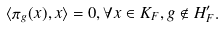Convert formula to latex. <formula><loc_0><loc_0><loc_500><loc_500>\langle \pi _ { g } ( x ) , x \rangle = 0 , \forall x \in K _ { F } , g \notin H ^ { \prime } _ { F } .</formula> 